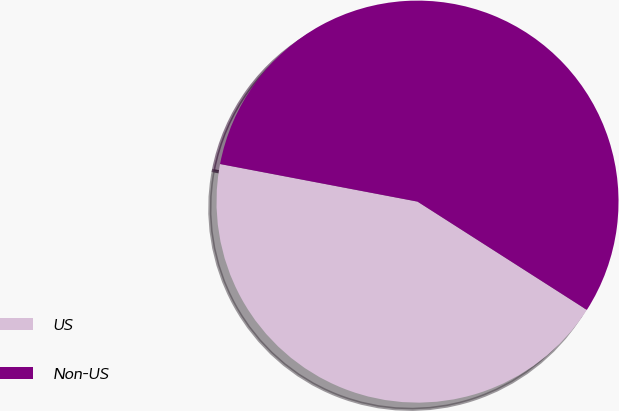Convert chart. <chart><loc_0><loc_0><loc_500><loc_500><pie_chart><fcel>US<fcel>Non-US<nl><fcel>43.94%<fcel>56.06%<nl></chart> 